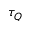Convert formula to latex. <formula><loc_0><loc_0><loc_500><loc_500>\tau _ { Q }</formula> 